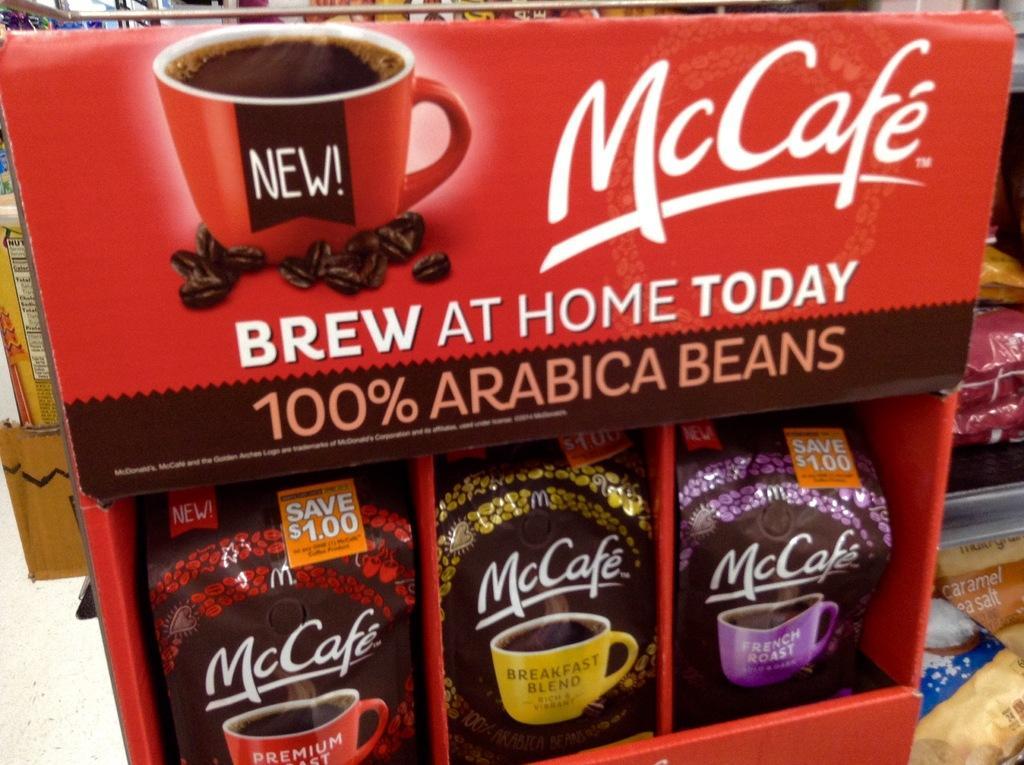In one or two sentences, can you explain what this image depicts? We can see packets in a box and we can see cup image on this box,beside this box we can see packets. 